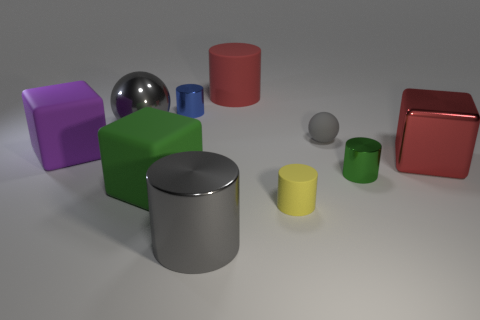There is a metal cylinder that is the same size as the green metallic thing; what is its color?
Your answer should be compact. Blue. How many large things are both behind the purple object and on the right side of the tiny blue cylinder?
Make the answer very short. 1. What is the material of the tiny blue cylinder?
Make the answer very short. Metal. What number of things are gray metallic spheres or tiny brown spheres?
Provide a short and direct response. 1. There is a gray object that is on the left side of the green cube; does it have the same size as the matte cylinder that is in front of the small blue metallic cylinder?
Give a very brief answer. No. What number of other objects are the same size as the red block?
Provide a short and direct response. 5. What number of things are rubber cylinders left of the tiny matte cylinder or large purple matte objects on the left side of the green cylinder?
Your answer should be very brief. 2. Is the material of the tiny blue cylinder the same as the tiny green thing that is to the right of the large purple thing?
Make the answer very short. Yes. What number of other things are there of the same shape as the yellow matte thing?
Ensure brevity in your answer.  4. There is a large cylinder behind the big block to the right of the gray metal thing right of the large gray sphere; what is its material?
Ensure brevity in your answer.  Rubber. 